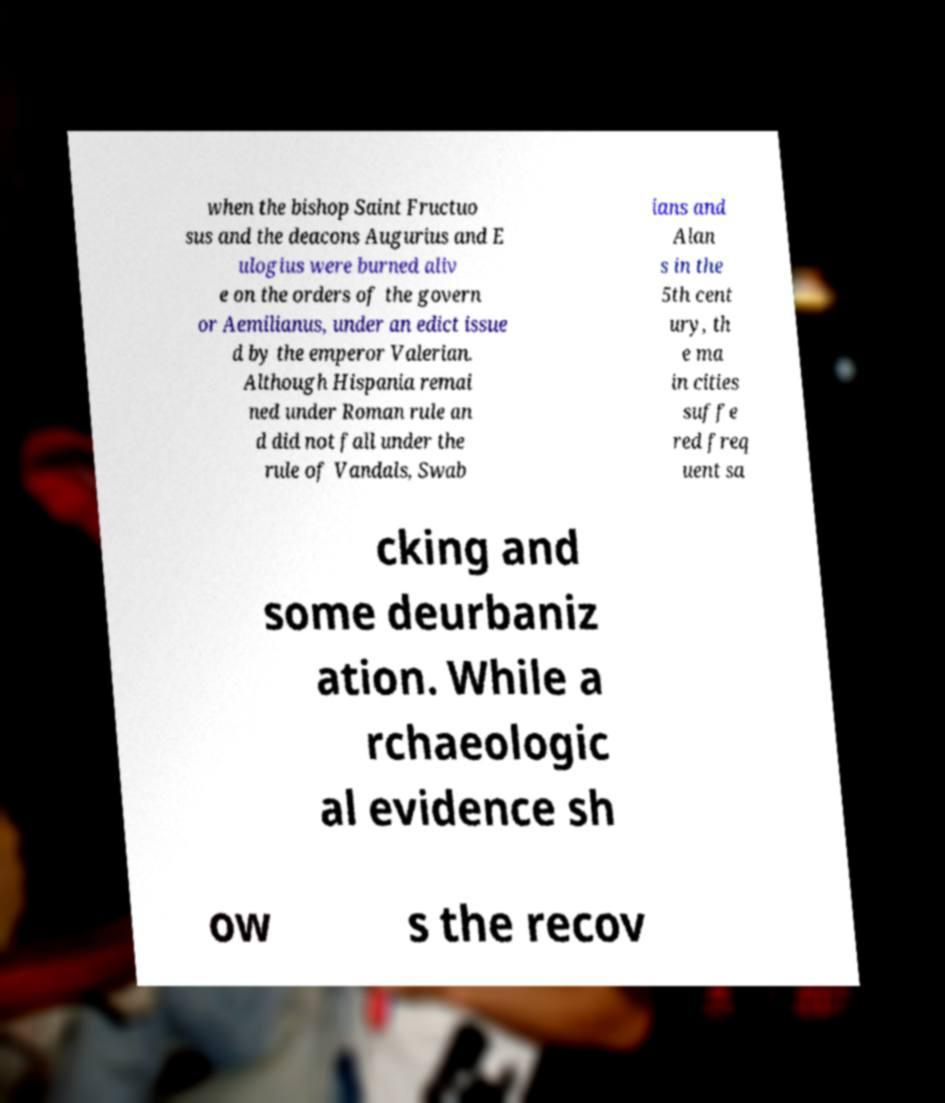For documentation purposes, I need the text within this image transcribed. Could you provide that? when the bishop Saint Fructuo sus and the deacons Augurius and E ulogius were burned aliv e on the orders of the govern or Aemilianus, under an edict issue d by the emperor Valerian. Although Hispania remai ned under Roman rule an d did not fall under the rule of Vandals, Swab ians and Alan s in the 5th cent ury, th e ma in cities suffe red freq uent sa cking and some deurbaniz ation. While a rchaeologic al evidence sh ow s the recov 